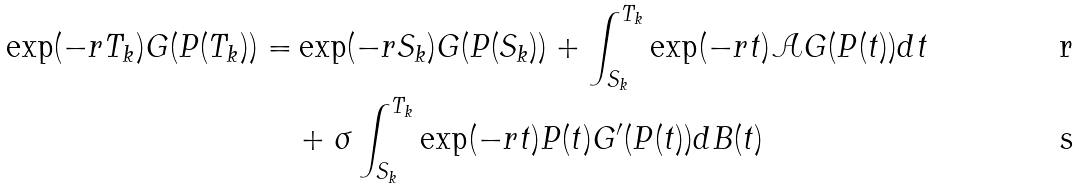<formula> <loc_0><loc_0><loc_500><loc_500>\exp ( - r T _ { k } ) G ( P ( T _ { k } ) ) = & \exp ( - r S _ { k } ) G ( P ( S _ { k } ) ) + \int _ { S _ { k } } ^ { T _ { k } } \exp ( - r t ) \mathcal { A } G ( P ( t ) ) d t \\ & + \sigma \int _ { S _ { k } } ^ { T _ { k } } \exp ( - r t ) P ( t ) G ^ { \prime } ( P ( t ) ) d B ( t )</formula> 